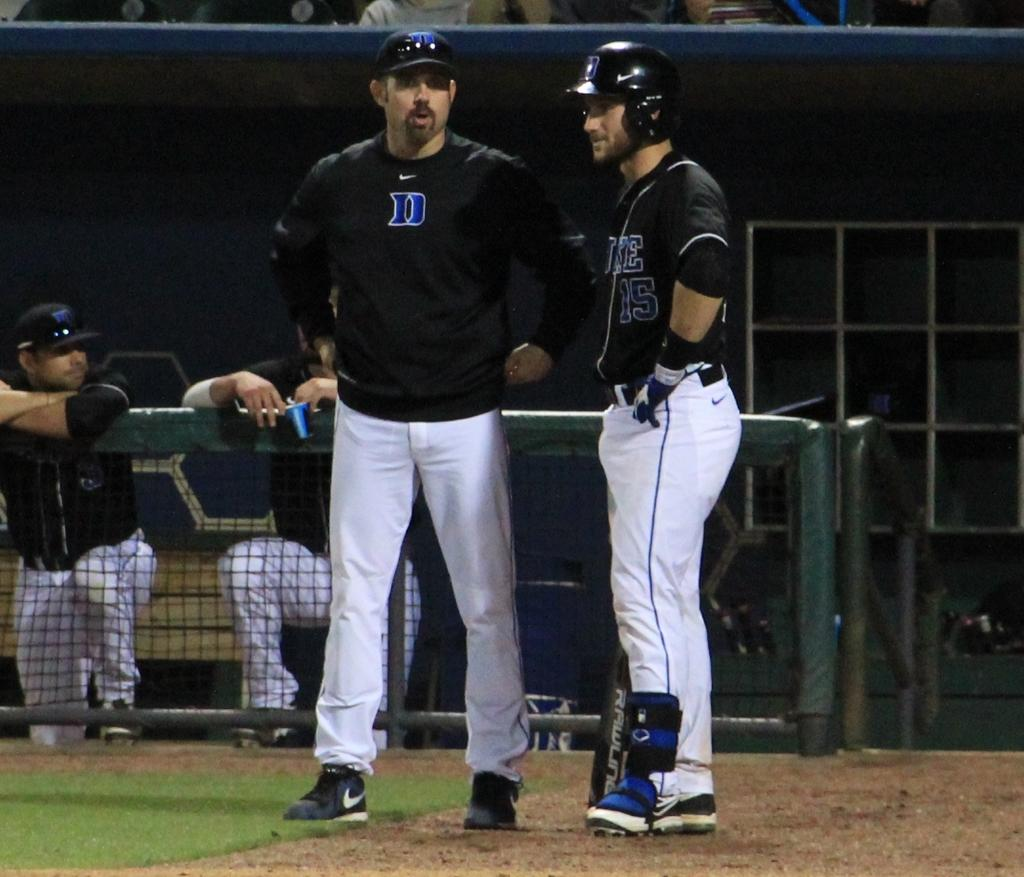<image>
Create a compact narrative representing the image presented. A Duke baseball player talks with a coach. 